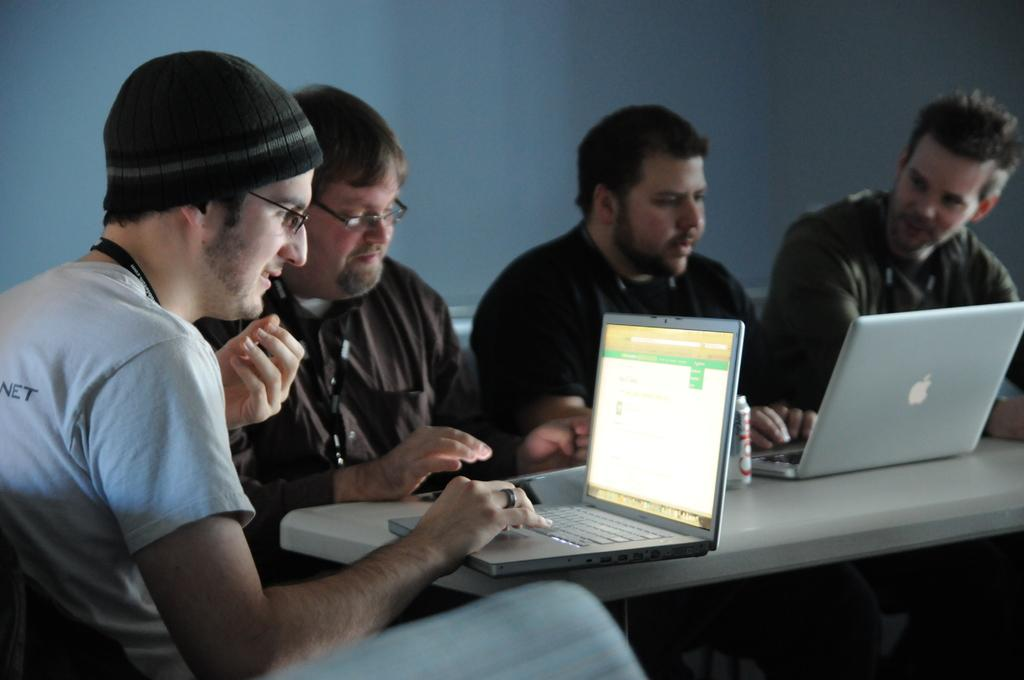What are the people in the image doing? The people in the image are sitting. What is in front of the people? There is a table in front of the people. What electronic devices can be seen on the table? There are two laptops on the table. What else is on the table besides the laptops? There is a tin on the table. What can be seen in the background of the image? There is a wall in the background of the image. What type of island can be seen in the background of the image? There is no island present in the image; it features a wall in the background. 